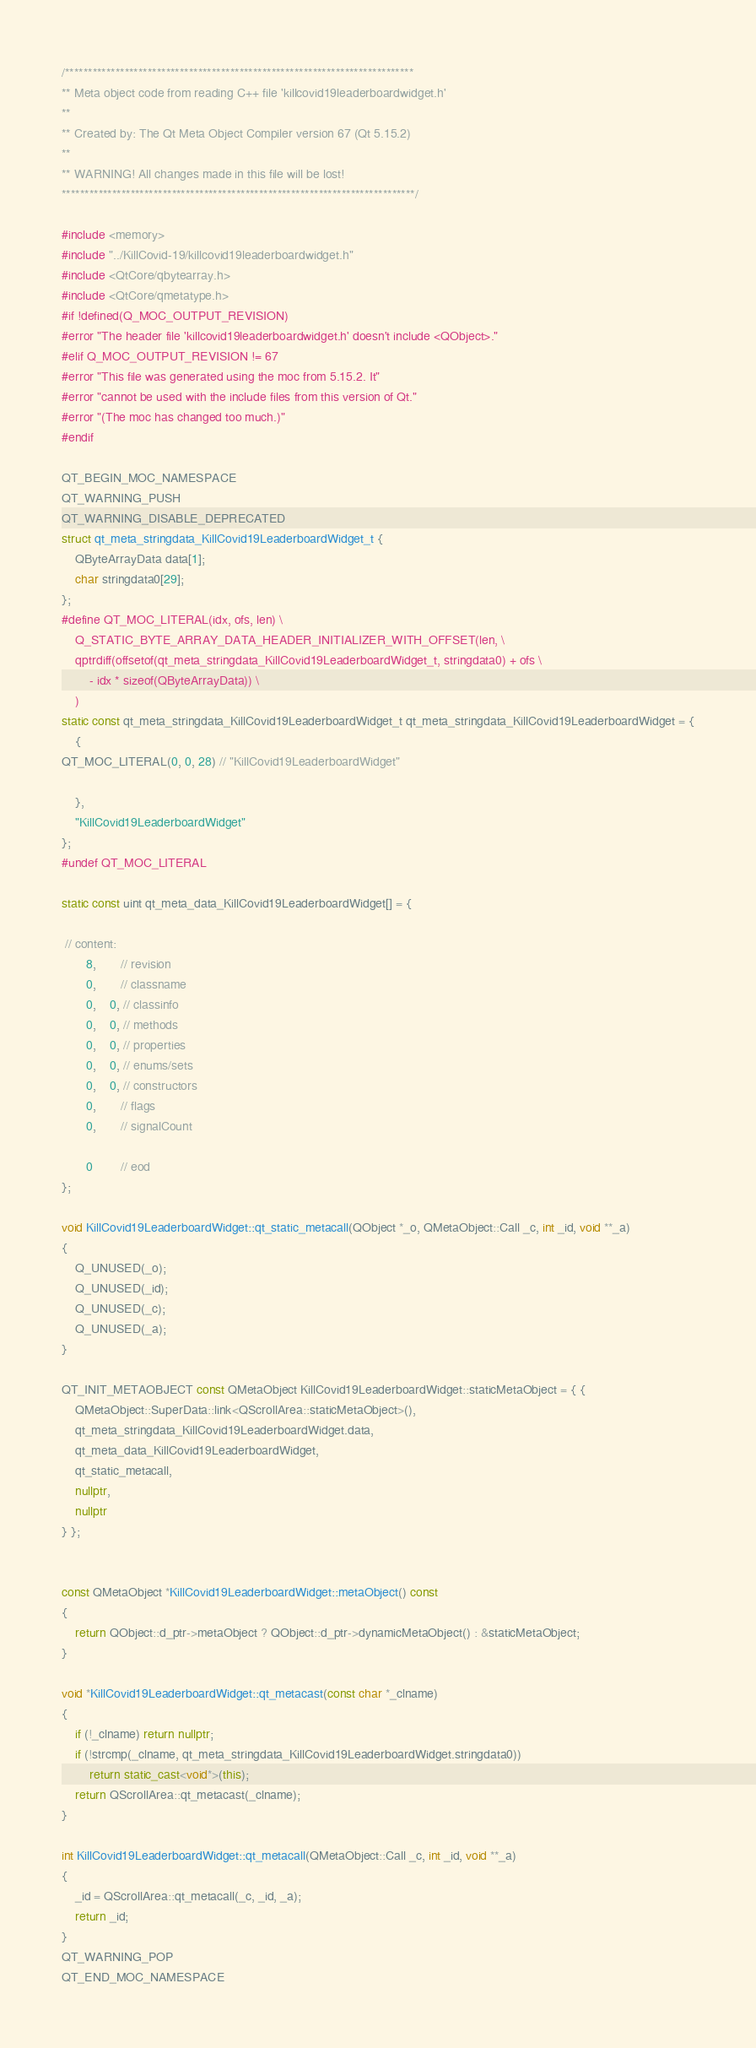Convert code to text. <code><loc_0><loc_0><loc_500><loc_500><_C++_>/****************************************************************************
** Meta object code from reading C++ file 'killcovid19leaderboardwidget.h'
**
** Created by: The Qt Meta Object Compiler version 67 (Qt 5.15.2)
**
** WARNING! All changes made in this file will be lost!
*****************************************************************************/

#include <memory>
#include "../KillCovid-19/killcovid19leaderboardwidget.h"
#include <QtCore/qbytearray.h>
#include <QtCore/qmetatype.h>
#if !defined(Q_MOC_OUTPUT_REVISION)
#error "The header file 'killcovid19leaderboardwidget.h' doesn't include <QObject>."
#elif Q_MOC_OUTPUT_REVISION != 67
#error "This file was generated using the moc from 5.15.2. It"
#error "cannot be used with the include files from this version of Qt."
#error "(The moc has changed too much.)"
#endif

QT_BEGIN_MOC_NAMESPACE
QT_WARNING_PUSH
QT_WARNING_DISABLE_DEPRECATED
struct qt_meta_stringdata_KillCovid19LeaderboardWidget_t {
    QByteArrayData data[1];
    char stringdata0[29];
};
#define QT_MOC_LITERAL(idx, ofs, len) \
    Q_STATIC_BYTE_ARRAY_DATA_HEADER_INITIALIZER_WITH_OFFSET(len, \
    qptrdiff(offsetof(qt_meta_stringdata_KillCovid19LeaderboardWidget_t, stringdata0) + ofs \
        - idx * sizeof(QByteArrayData)) \
    )
static const qt_meta_stringdata_KillCovid19LeaderboardWidget_t qt_meta_stringdata_KillCovid19LeaderboardWidget = {
    {
QT_MOC_LITERAL(0, 0, 28) // "KillCovid19LeaderboardWidget"

    },
    "KillCovid19LeaderboardWidget"
};
#undef QT_MOC_LITERAL

static const uint qt_meta_data_KillCovid19LeaderboardWidget[] = {

 // content:
       8,       // revision
       0,       // classname
       0,    0, // classinfo
       0,    0, // methods
       0,    0, // properties
       0,    0, // enums/sets
       0,    0, // constructors
       0,       // flags
       0,       // signalCount

       0        // eod
};

void KillCovid19LeaderboardWidget::qt_static_metacall(QObject *_o, QMetaObject::Call _c, int _id, void **_a)
{
    Q_UNUSED(_o);
    Q_UNUSED(_id);
    Q_UNUSED(_c);
    Q_UNUSED(_a);
}

QT_INIT_METAOBJECT const QMetaObject KillCovid19LeaderboardWidget::staticMetaObject = { {
    QMetaObject::SuperData::link<QScrollArea::staticMetaObject>(),
    qt_meta_stringdata_KillCovid19LeaderboardWidget.data,
    qt_meta_data_KillCovid19LeaderboardWidget,
    qt_static_metacall,
    nullptr,
    nullptr
} };


const QMetaObject *KillCovid19LeaderboardWidget::metaObject() const
{
    return QObject::d_ptr->metaObject ? QObject::d_ptr->dynamicMetaObject() : &staticMetaObject;
}

void *KillCovid19LeaderboardWidget::qt_metacast(const char *_clname)
{
    if (!_clname) return nullptr;
    if (!strcmp(_clname, qt_meta_stringdata_KillCovid19LeaderboardWidget.stringdata0))
        return static_cast<void*>(this);
    return QScrollArea::qt_metacast(_clname);
}

int KillCovid19LeaderboardWidget::qt_metacall(QMetaObject::Call _c, int _id, void **_a)
{
    _id = QScrollArea::qt_metacall(_c, _id, _a);
    return _id;
}
QT_WARNING_POP
QT_END_MOC_NAMESPACE
</code> 